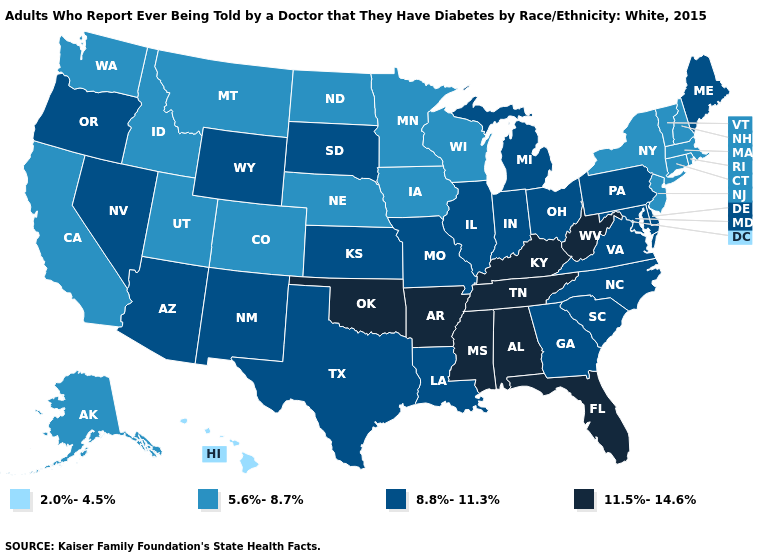Does Vermont have the lowest value in the Northeast?
Concise answer only. Yes. How many symbols are there in the legend?
Concise answer only. 4. Does New Hampshire have a higher value than Hawaii?
Keep it brief. Yes. Does Mississippi have a higher value than Alabama?
Keep it brief. No. What is the lowest value in the USA?
Answer briefly. 2.0%-4.5%. Does New York have the same value as Georgia?
Quick response, please. No. What is the highest value in the Northeast ?
Write a very short answer. 8.8%-11.3%. What is the value of Minnesota?
Keep it brief. 5.6%-8.7%. Name the states that have a value in the range 5.6%-8.7%?
Short answer required. Alaska, California, Colorado, Connecticut, Idaho, Iowa, Massachusetts, Minnesota, Montana, Nebraska, New Hampshire, New Jersey, New York, North Dakota, Rhode Island, Utah, Vermont, Washington, Wisconsin. What is the lowest value in the USA?
Give a very brief answer. 2.0%-4.5%. Does Arizona have the lowest value in the USA?
Give a very brief answer. No. What is the value of Texas?
Quick response, please. 8.8%-11.3%. Name the states that have a value in the range 5.6%-8.7%?
Keep it brief. Alaska, California, Colorado, Connecticut, Idaho, Iowa, Massachusetts, Minnesota, Montana, Nebraska, New Hampshire, New Jersey, New York, North Dakota, Rhode Island, Utah, Vermont, Washington, Wisconsin. What is the value of Delaware?
Short answer required. 8.8%-11.3%. 